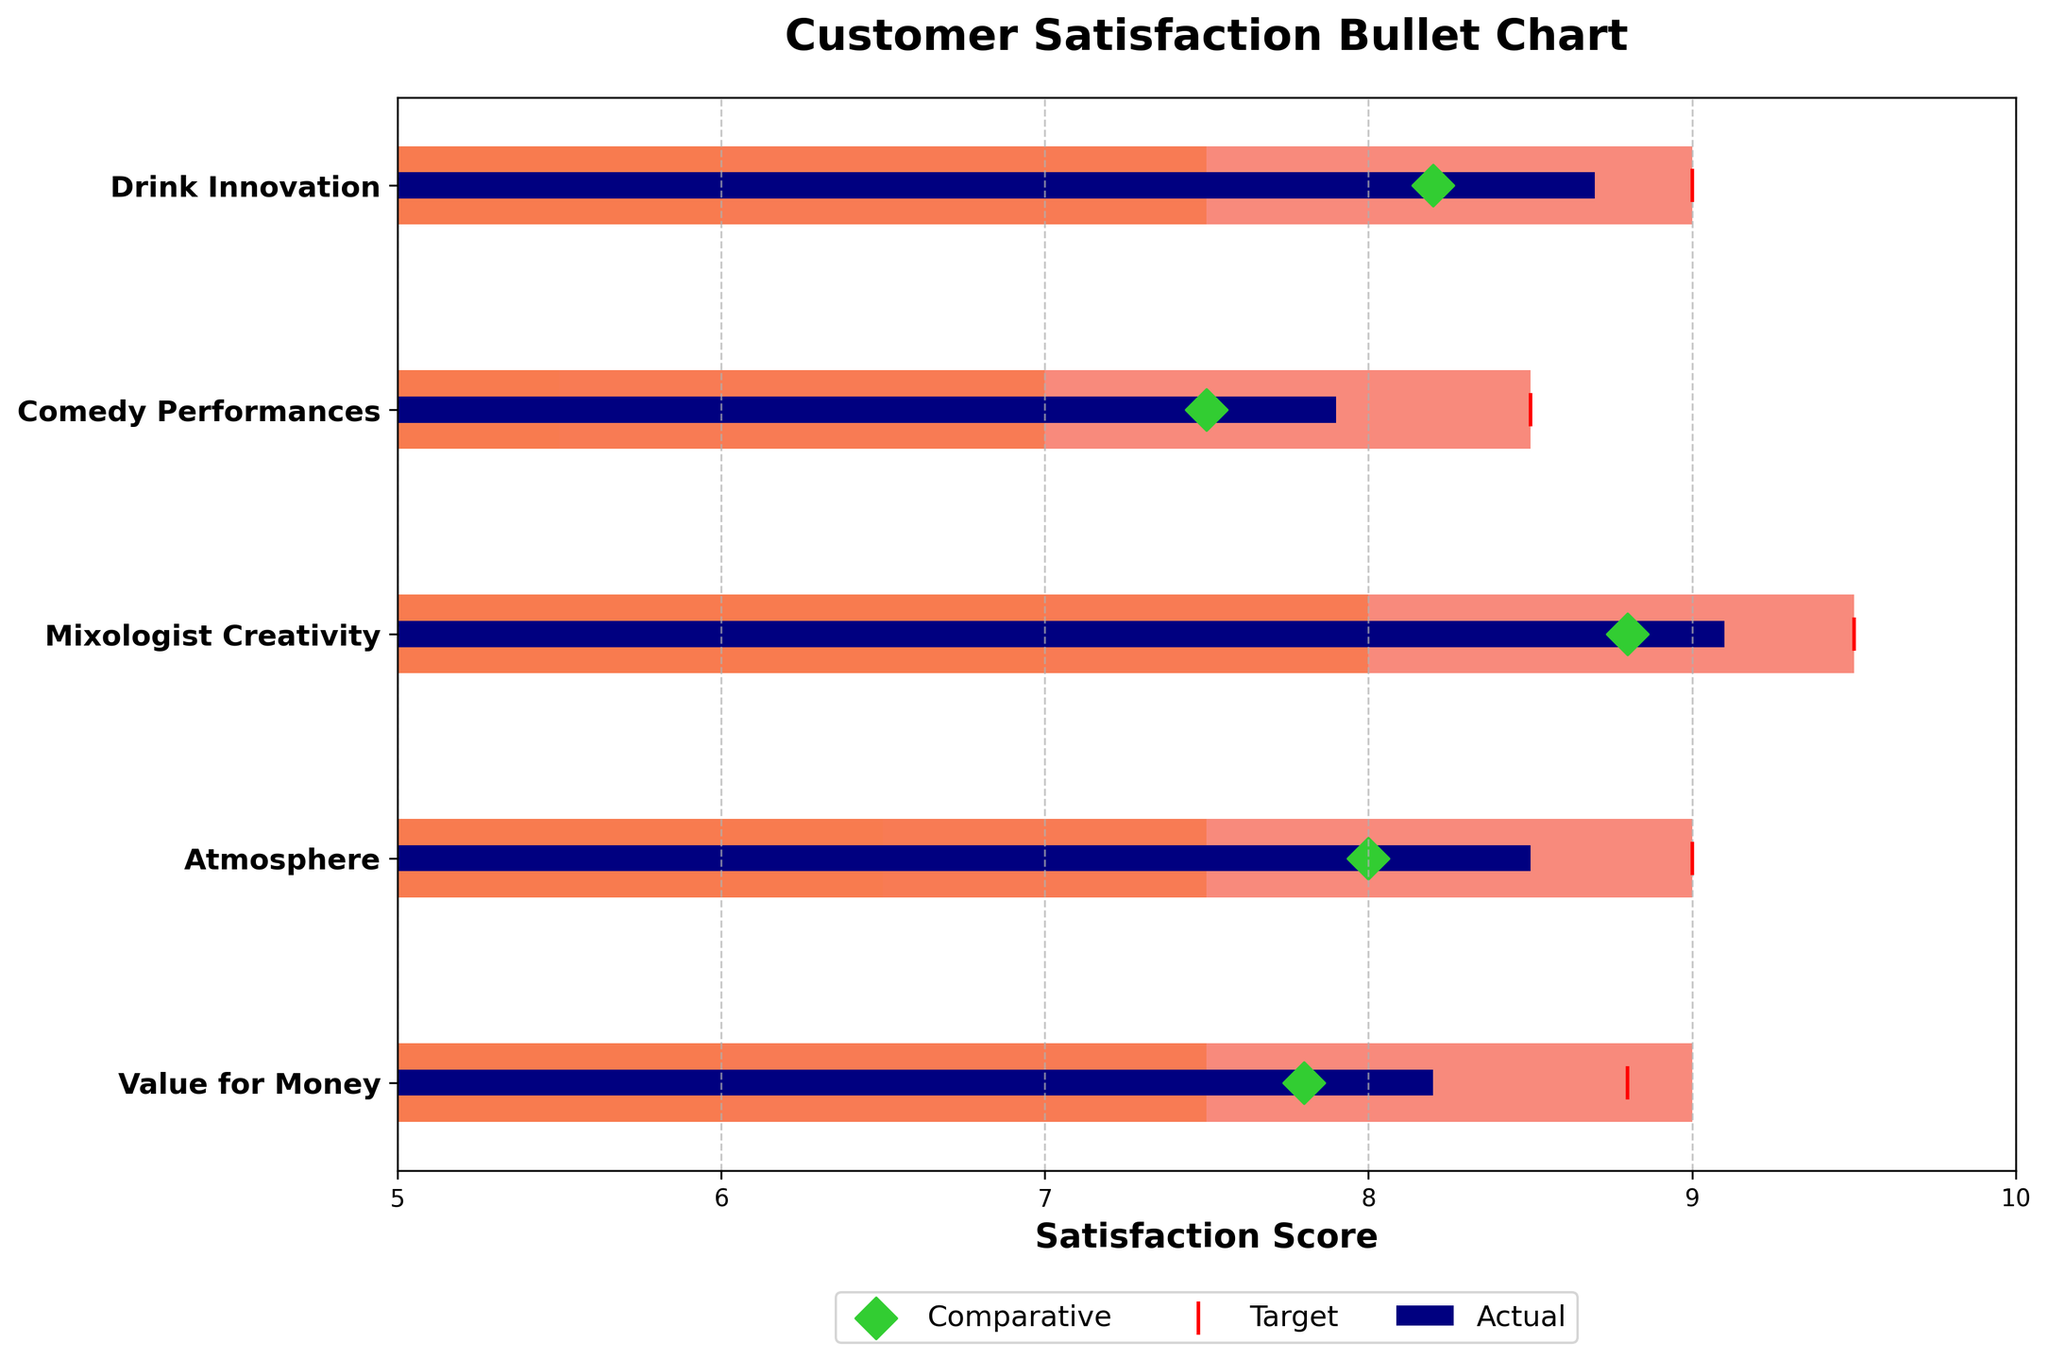What is the actual satisfaction score for Drink Innovation? The actual satisfaction score can be found by looking at the blue bar next to the category "Drink Innovation".
Answer: 8.7 Which category has the highest target satisfaction score? The highest target score is indicated by the red vertical line furthest to the right. By comparing the red lines, Mixologist Creativity stands out with the highest target score.
Answer: Mixologist Creativity How does the actual score for Comedy Performances compare to its target score? The actual score for Comedy Performances is 7.9, while the target score is 8.5. Therefore, the actual score is lower than the target.
Answer: Lower What is the range of satisfactory scores for Atmosphere? The range can be interpreted from the colored bars behind the actual value. For Atmosphere, the satisfactory range goes from 6.5 to 7.5.
Answer: 6.5 to 7.5 Which category has a comparative score closest to its actual score? To find this, we look for the smallest gap between the actual (blue bar) and comparative (green diamond) scores. For Drink Innovation, the actual score is 8.7 and the comparative score is 8.2, a difference of 0.5. For Comedy Performances, it's a difference of 0.4. For Mixologist Creativity, it's 0.3. For Atmosphere, it's 0.5. For Value for Money, it's 0.4. Mixologist Creativity has the smallest difference of 0.3.
Answer: Mixologist Creativity Which category does not meet its satisfactory range according to the actual score? Satisfactory range is defined by the first colored range. Any actual score lower than this range means it does not meet the satisfactory range. All actual values are within their respective ranges, but when comparing closely, Comedy Performances is on the edge of not meeting the range.
Answer: Comedy Performances What is the difference between the actual satisfaction scores of Mixologist Creativity and Drink Innovation? The actual scores for Mixologist Creativity and Drink Innovation are 9.1 and 8.7 respectively. The difference is calculated by subtracting 8.7 from 9.1.
Answer: 0.4 Which category shows the biggest gap between comparative and target scores? To find this, compare the distances between the green diamond and the red line in each category. Drink Innovation: 0.8, Comedy Performances: 1.0, Mixologist Creativity: 0.7, Atmosphere: 1.0, Value for Money: 1.0. Comedy Performances, Atmosphere, and Value for Money have the biggest gap of 1.0.
Answer: Comedy Performances, Atmosphere, Value for Money What is the average of the target satisfaction scores across all categories? The target scores are 9.0 (Drink Innovation), 8.5 (Comedy Performances), 9.5 (Mixologist Creativity), 9.0 (Atmosphere), and 8.8 (Value for Money). The sum is 9.0 + 8.5 + 9.5 + 9.0 + 8.8 = 44.8. There are 5 categories, so the average is 44.8 / 5.
Answer: 8.96 